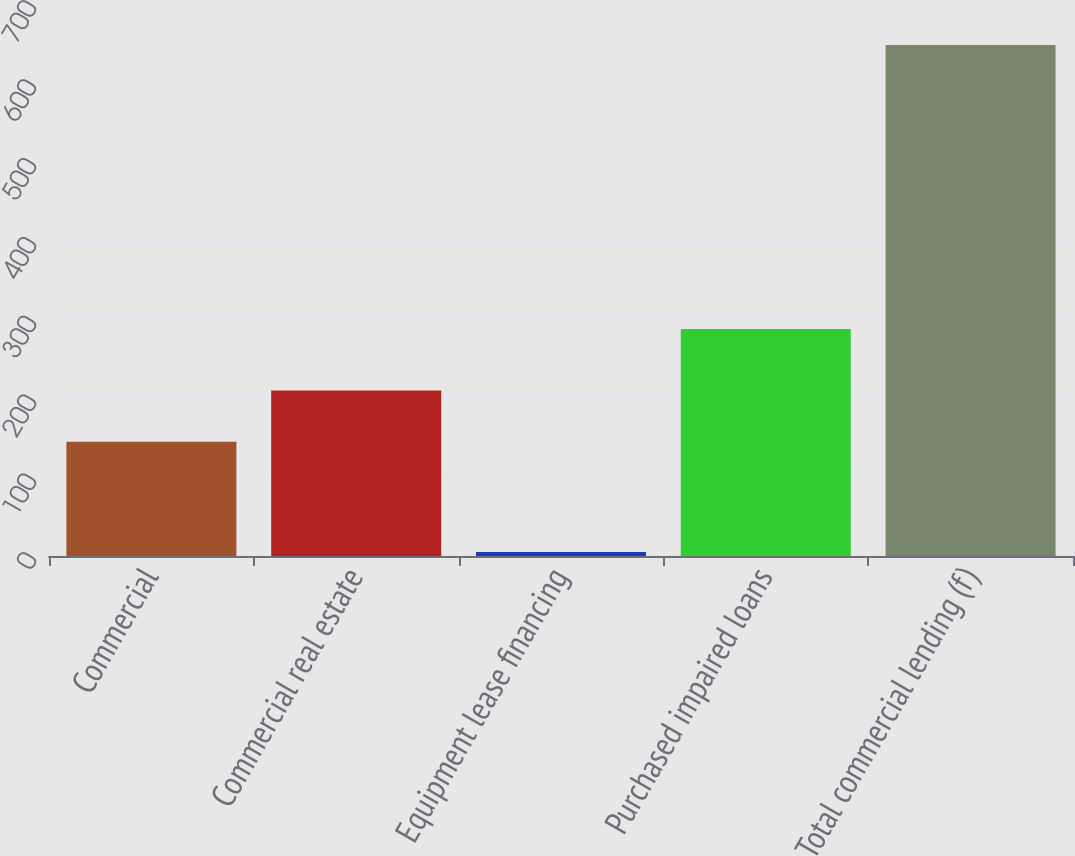<chart> <loc_0><loc_0><loc_500><loc_500><bar_chart><fcel>Commercial<fcel>Commercial real estate<fcel>Equipment lease financing<fcel>Purchased impaired loans<fcel>Total commercial lending (f)<nl><fcel>145<fcel>210<fcel>5<fcel>288<fcel>648<nl></chart> 